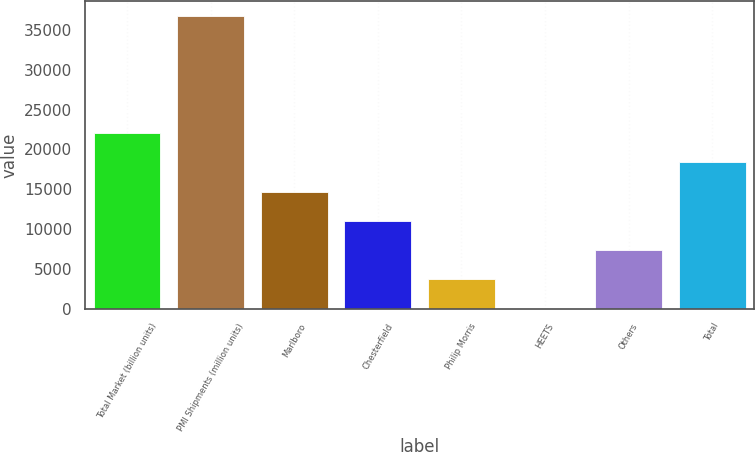<chart> <loc_0><loc_0><loc_500><loc_500><bar_chart><fcel>Total Market (billion units)<fcel>PMI Shipments (million units)<fcel>Marlboro<fcel>Chesterfield<fcel>Philip Morris<fcel>HEETS<fcel>Others<fcel>Total<nl><fcel>22060.5<fcel>36767<fcel>14707.2<fcel>11030.6<fcel>3677.33<fcel>0.7<fcel>7353.96<fcel>18383.8<nl></chart> 